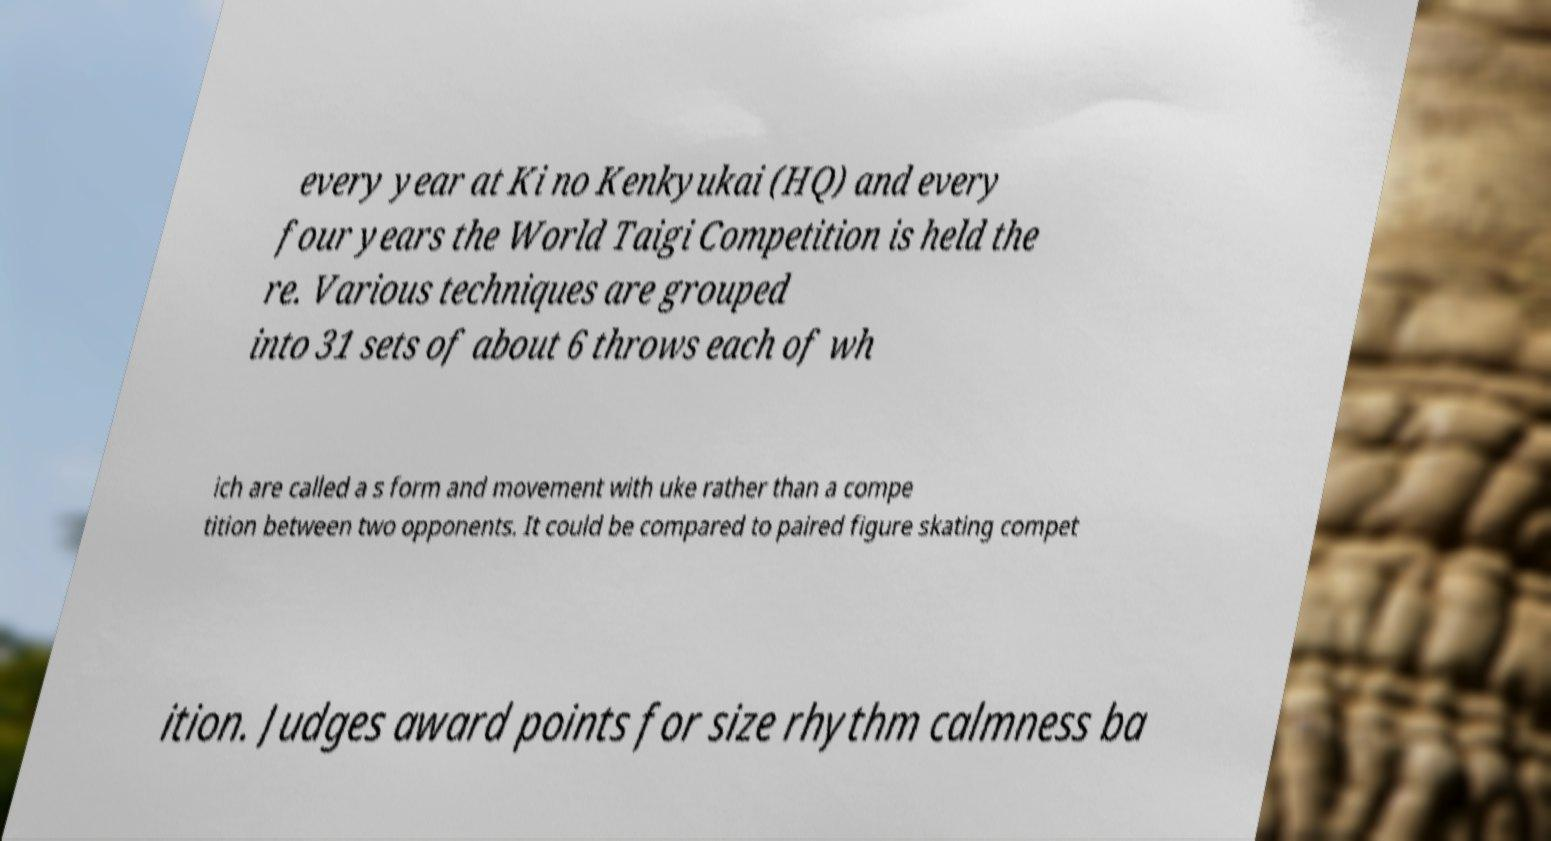Could you assist in decoding the text presented in this image and type it out clearly? every year at Ki no Kenkyukai (HQ) and every four years the World Taigi Competition is held the re. Various techniques are grouped into 31 sets of about 6 throws each of wh ich are called a s form and movement with uke rather than a compe tition between two opponents. It could be compared to paired figure skating compet ition. Judges award points for size rhythm calmness ba 